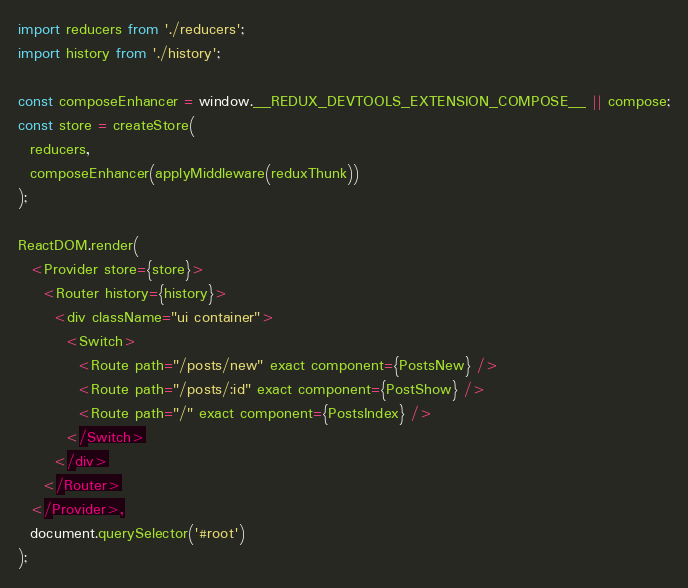<code> <loc_0><loc_0><loc_500><loc_500><_JavaScript_>import reducers from './reducers';
import history from './history';

const composeEnhancer = window.__REDUX_DEVTOOLS_EXTENSION_COMPOSE__ || compose;
const store = createStore(
  reducers,
  composeEnhancer(applyMiddleware(reduxThunk))
);

ReactDOM.render(
  <Provider store={store}>
    <Router history={history}>
      <div className="ui container">
        <Switch>
          <Route path="/posts/new" exact component={PostsNew} />
          <Route path="/posts/:id" exact component={PostShow} />
          <Route path="/" exact component={PostsIndex} />
        </Switch>
      </div>
    </Router>
  </Provider>,
  document.querySelector('#root')
);
</code> 